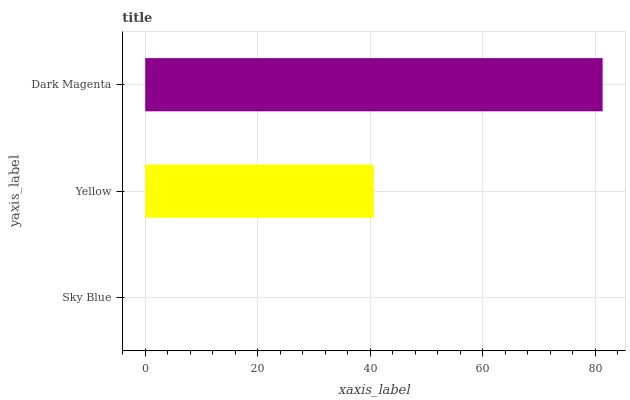Is Sky Blue the minimum?
Answer yes or no. Yes. Is Dark Magenta the maximum?
Answer yes or no. Yes. Is Yellow the minimum?
Answer yes or no. No. Is Yellow the maximum?
Answer yes or no. No. Is Yellow greater than Sky Blue?
Answer yes or no. Yes. Is Sky Blue less than Yellow?
Answer yes or no. Yes. Is Sky Blue greater than Yellow?
Answer yes or no. No. Is Yellow less than Sky Blue?
Answer yes or no. No. Is Yellow the high median?
Answer yes or no. Yes. Is Yellow the low median?
Answer yes or no. Yes. Is Dark Magenta the high median?
Answer yes or no. No. Is Sky Blue the low median?
Answer yes or no. No. 